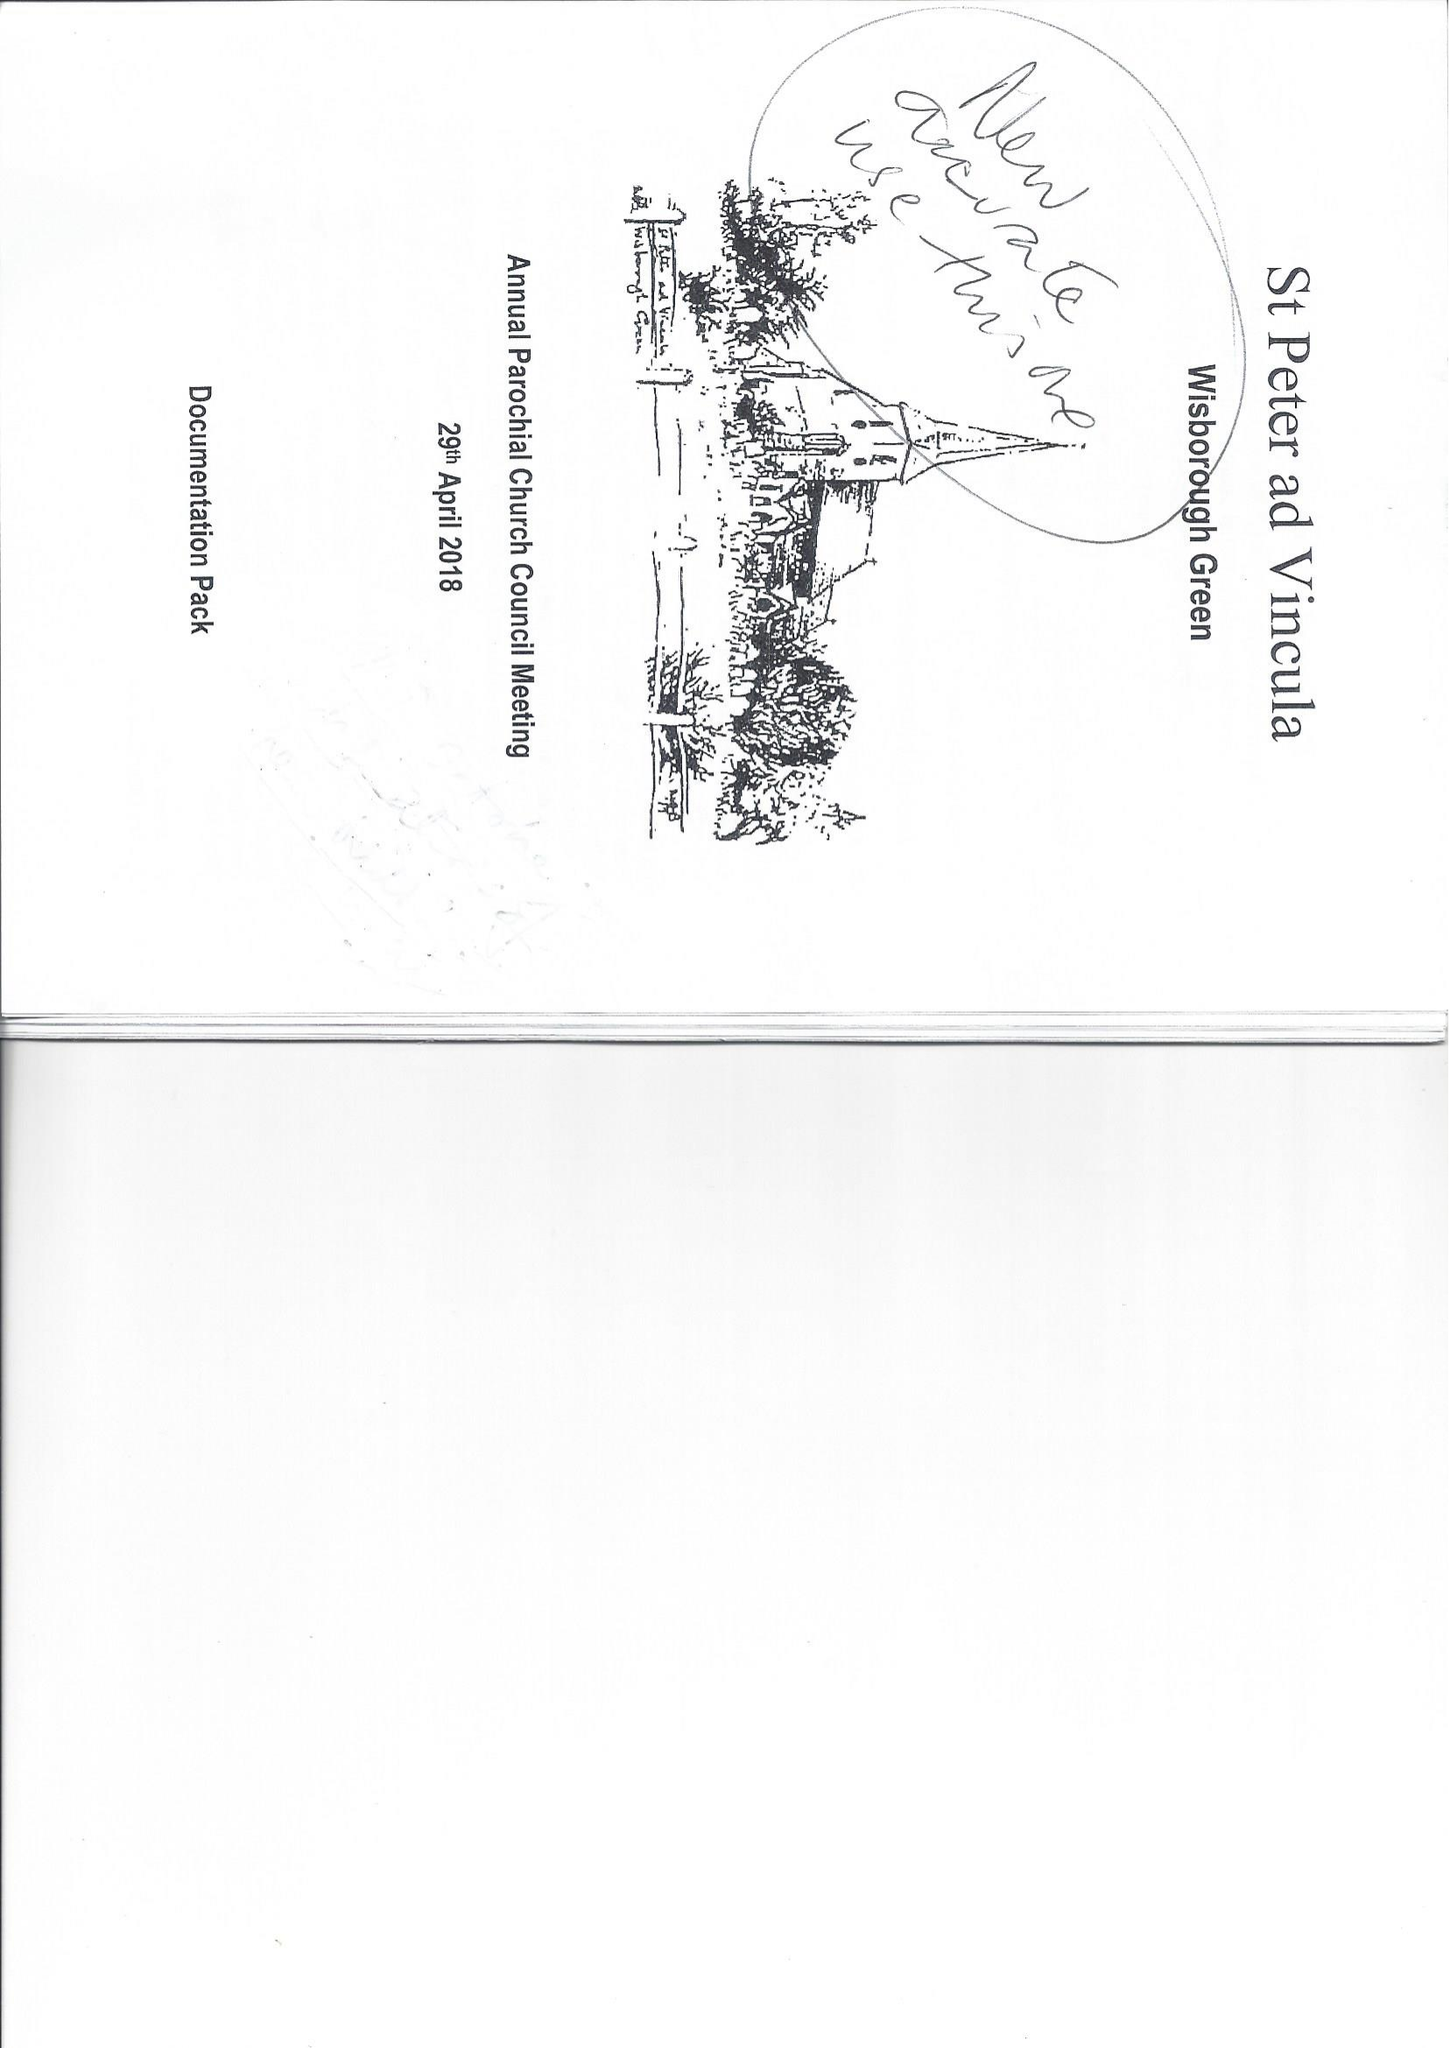What is the value for the spending_annually_in_british_pounds?
Answer the question using a single word or phrase. 112305.00 